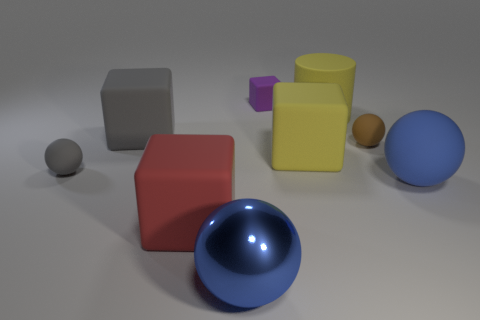Subtract 0 cyan blocks. How many objects are left? 9 Subtract all cubes. How many objects are left? 5 Subtract 3 blocks. How many blocks are left? 1 Subtract all purple balls. Subtract all gray cubes. How many balls are left? 4 Subtract all blue cylinders. How many brown balls are left? 1 Subtract all small brown matte objects. Subtract all blue metallic balls. How many objects are left? 7 Add 5 large gray matte blocks. How many large gray matte blocks are left? 6 Add 8 blue metal spheres. How many blue metal spheres exist? 9 Add 1 tiny spheres. How many objects exist? 10 Subtract all brown balls. How many balls are left? 3 